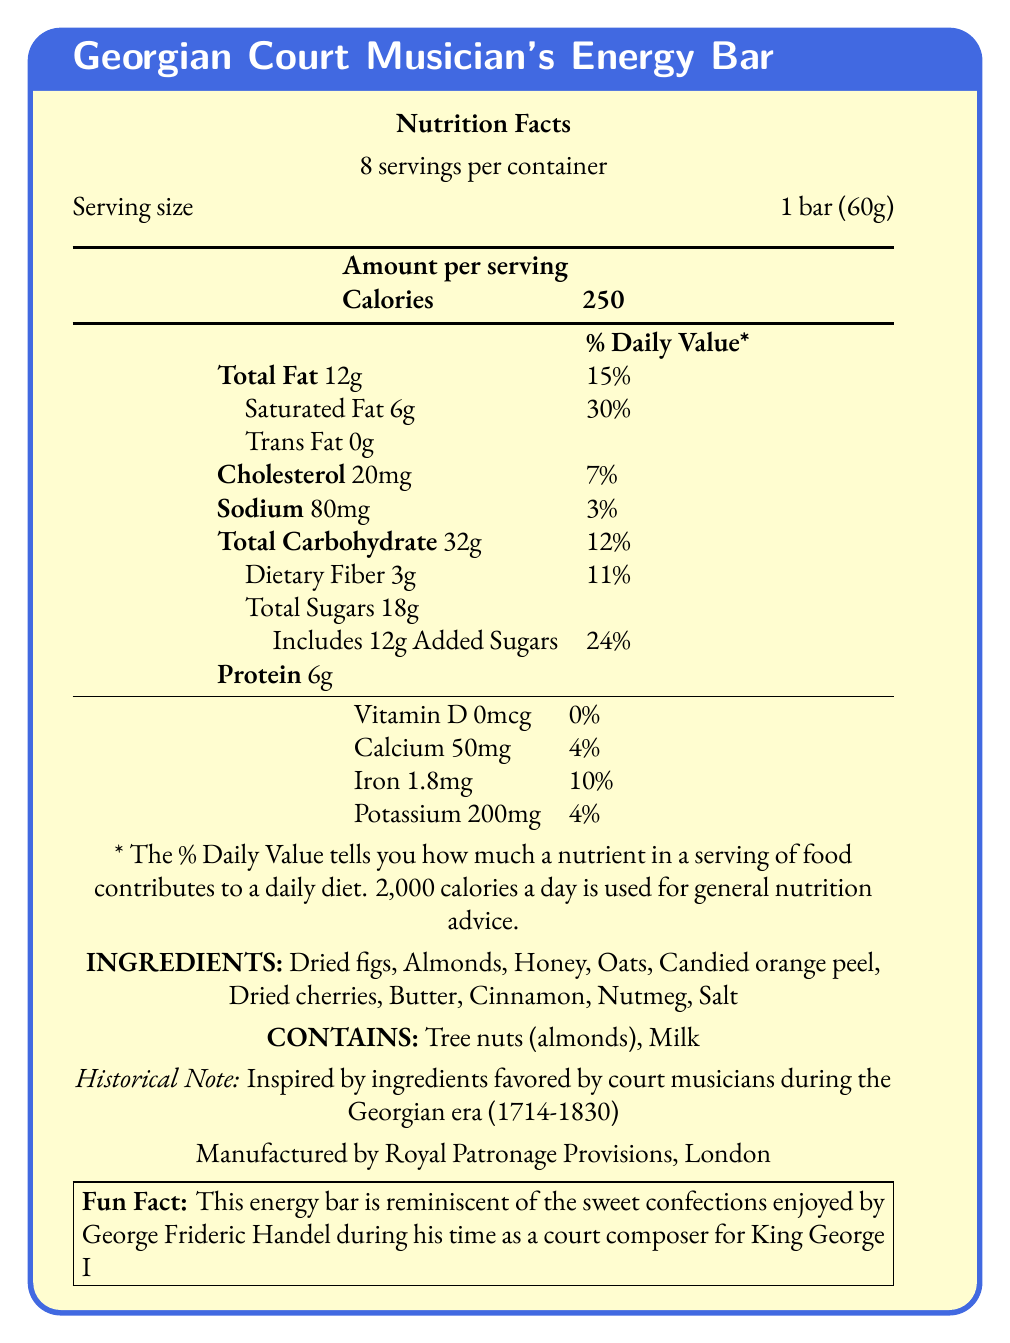what is the serving size? The serving size is explicitly mentioned as "1 bar (60g)" in the document.
Answer: 1 bar (60g) how many servings are there per container? The document states there are 8 servings per container.
Answer: 8 what is the amount of total fat per serving? The amount of total fat per serving is listed as 12g.
Answer: 12g who manufactured the energy bar? The document indicates that the energy bar is manufactured by Royal Patronage Provisions, London.
Answer: Royal Patronage Provisions, London does the energy bar contain any tree nuts? The allergen information specifies that the bar contains tree nuts (almonds).
Answer: Yes what is the % Daily Value of dietary fiber? The % Daily Value of dietary fiber is listed as 11%.
Answer: 11% how many grams of protein are in one serving? The document lists the amount of protein per serving as 6g.
Answer: 6g which vitamin has a 0% daily value? A. Vitamin D B. Calcium C. Iron D. Potassium The document lists that Vitamin D has a 0% daily value.
Answer: A what type of fat is not present in the energy bar? A. Saturated Fat B. Trans Fat C. Total Fat The document shows Trans Fat as 0g, meaning it is not present.
Answer: B which historical figure enjoyed these types of confections? A. Wolfgang Amadeus Mozart B. Ludwig van Beethoven C. George Frideric Handel The fun fact mentions that George Frideric Handel enjoyed such confections.
Answer: C is there any added sugar in the energy bar? The document lists that the energy bar includes 12g of added sugars.
Answer: Yes is the energy bar gluten-free? The document does not provide explicit information about whether the energy bar is gluten-free.
Answer: Not enough information summarize the main idea of the document. The summary includes key information about the product, its nutritional content, ingredients, historical connection, and manufacturer details based on the document.
Answer: The Georgian Court Musician's Energy Bar is a 60g bar inspired by ingredients favored during the Georgian era. It contains 250 calories, 12g of total fat, 6g of protein, and includes ingredients such as dried figs, almonds, and honey. The document provides detailed nutrition facts, allergen information, and a historical note linking the bar to confections enjoyed by George Frideric Handel. The manufacturer is Royal Patronage Provisions, London. 